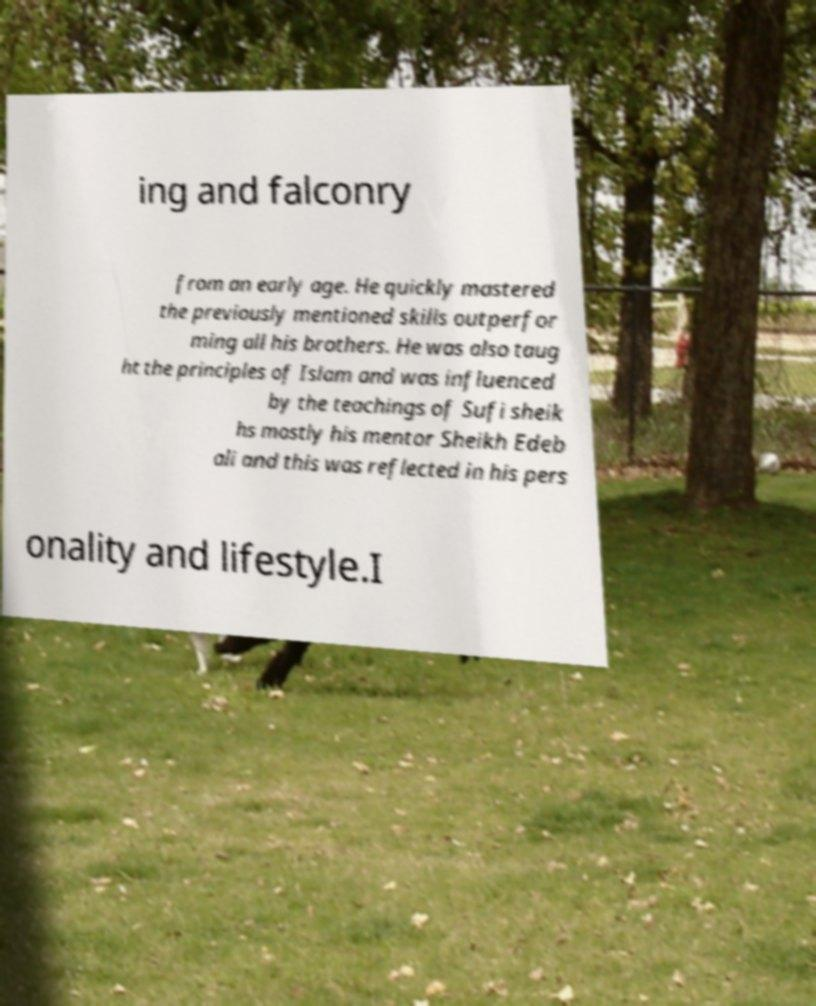Please read and relay the text visible in this image. What does it say? ing and falconry from an early age. He quickly mastered the previously mentioned skills outperfor ming all his brothers. He was also taug ht the principles of Islam and was influenced by the teachings of Sufi sheik hs mostly his mentor Sheikh Edeb ali and this was reflected in his pers onality and lifestyle.I 